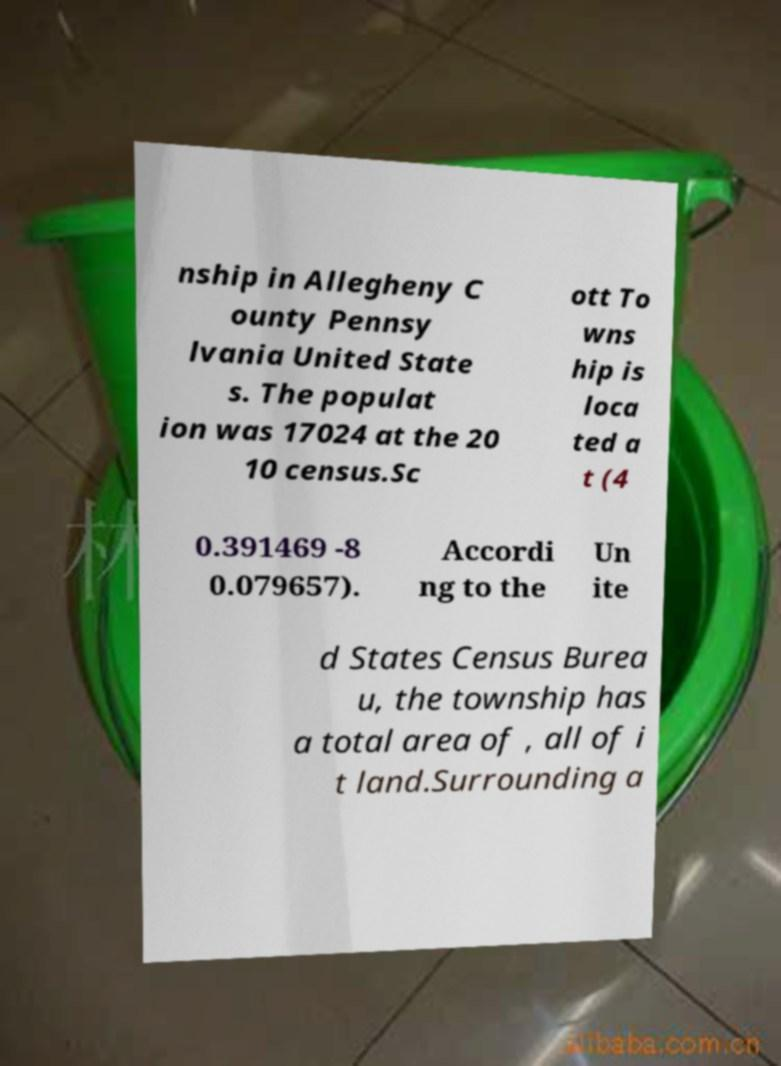Please read and relay the text visible in this image. What does it say? nship in Allegheny C ounty Pennsy lvania United State s. The populat ion was 17024 at the 20 10 census.Sc ott To wns hip is loca ted a t (4 0.391469 -8 0.079657). Accordi ng to the Un ite d States Census Burea u, the township has a total area of , all of i t land.Surrounding a 